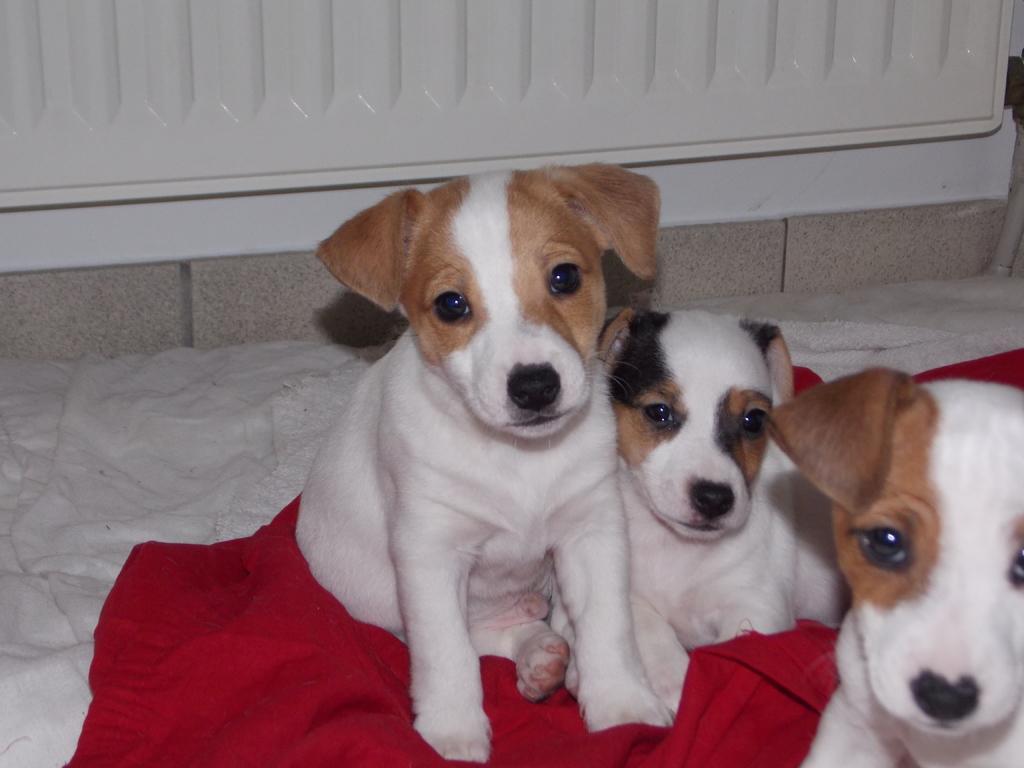Describe this image in one or two sentences. In this image I can see few animals which are in white, brown and black color. These are on the red and white color cloth. I can see the white and ash color background. 